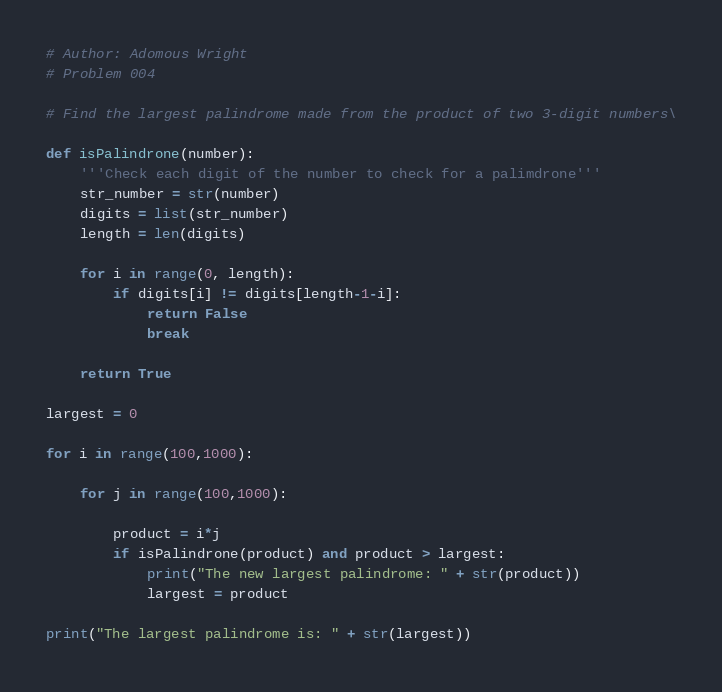<code> <loc_0><loc_0><loc_500><loc_500><_Python_># Author: Adomous Wright
# Problem 004

# Find the largest palindrome made from the product of two 3-digit numbers\

def isPalindrone(number):
    '''Check each digit of the number to check for a palimdrone'''
    str_number = str(number)
    digits = list(str_number)
    length = len(digits)

    for i in range(0, length):
        if digits[i] != digits[length-1-i]:
            return False
            break

    return True

largest = 0

for i in range(100,1000):

    for j in range(100,1000):

        product = i*j
        if isPalindrone(product) and product > largest:
            print("The new largest palindrome: " + str(product))
            largest = product

print("The largest palindrome is: " + str(largest))
</code> 